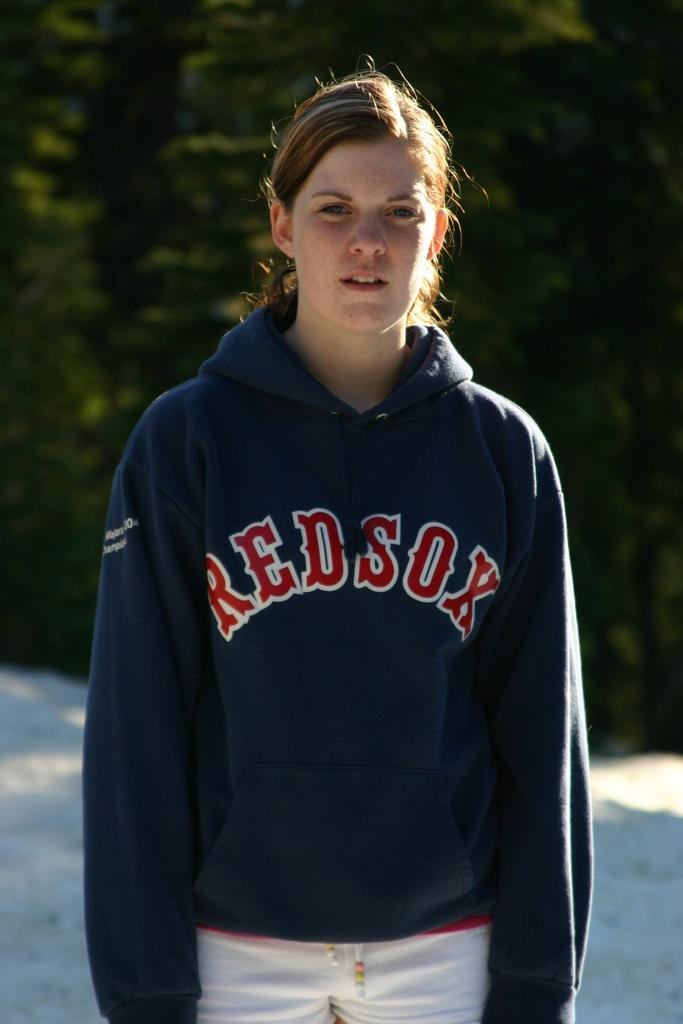<image>
Give a short and clear explanation of the subsequent image. A girl with a blue sweater with the red sox logo 